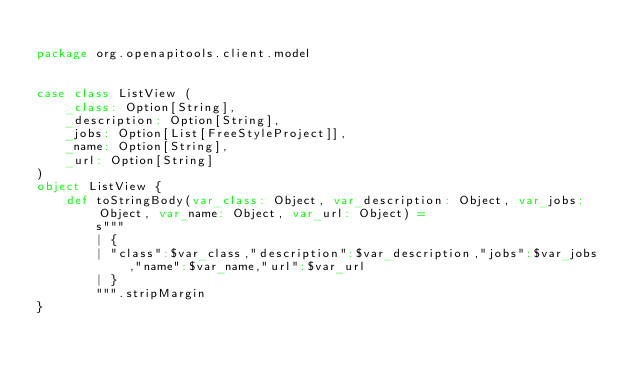<code> <loc_0><loc_0><loc_500><loc_500><_Scala_>
package org.openapitools.client.model


case class ListView (
    _class: Option[String],
    _description: Option[String],
    _jobs: Option[List[FreeStyleProject]],
    _name: Option[String],
    _url: Option[String]
)
object ListView {
    def toStringBody(var_class: Object, var_description: Object, var_jobs: Object, var_name: Object, var_url: Object) =
        s"""
        | {
        | "class":$var_class,"description":$var_description,"jobs":$var_jobs,"name":$var_name,"url":$var_url
        | }
        """.stripMargin
}
</code> 